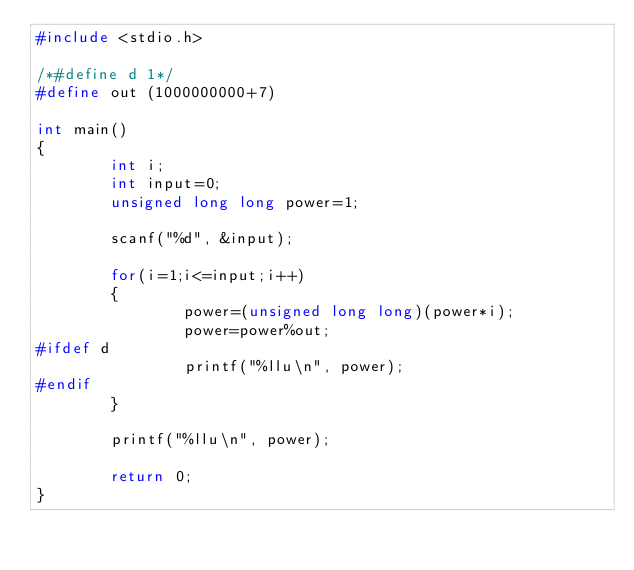<code> <loc_0><loc_0><loc_500><loc_500><_C_>#include <stdio.h>

/*#define d 1*/
#define out (1000000000+7)

int main()
{
        int i;
        int input=0;
        unsigned long long power=1;

        scanf("%d", &input);

        for(i=1;i<=input;i++)
        {
                power=(unsigned long long)(power*i);
                power=power%out;
#ifdef d
                printf("%llu\n", power);
#endif
        }

        printf("%llu\n", power);

        return 0;
}</code> 